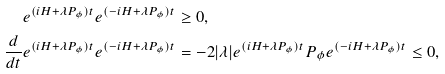Convert formula to latex. <formula><loc_0><loc_0><loc_500><loc_500>e ^ { ( i H + \lambda P _ { \phi } ) t } e ^ { ( - i H + \lambda P _ { \phi } ) t } & \geq 0 , \\ \frac { d } { d t } e ^ { ( i H + \lambda P _ { \phi } ) t } e ^ { ( - i H + \lambda P _ { \phi } ) t } & = - 2 | \lambda | e ^ { ( i H + \lambda P _ { \phi } ) t } P _ { \phi } e ^ { ( - i H + \lambda P _ { \phi } ) t } \leq 0 ,</formula> 